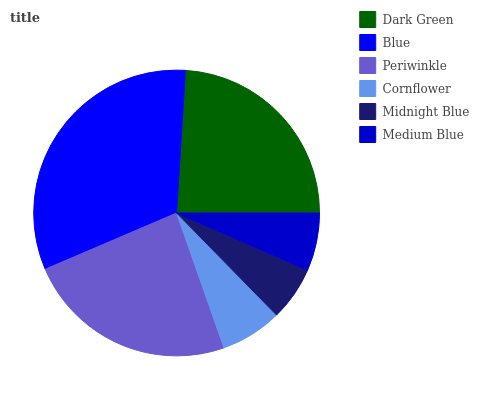Is Midnight Blue the minimum?
Answer yes or no. Yes. Is Blue the maximum?
Answer yes or no. Yes. Is Periwinkle the minimum?
Answer yes or no. No. Is Periwinkle the maximum?
Answer yes or no. No. Is Blue greater than Periwinkle?
Answer yes or no. Yes. Is Periwinkle less than Blue?
Answer yes or no. Yes. Is Periwinkle greater than Blue?
Answer yes or no. No. Is Blue less than Periwinkle?
Answer yes or no. No. Is Periwinkle the high median?
Answer yes or no. Yes. Is Cornflower the low median?
Answer yes or no. Yes. Is Dark Green the high median?
Answer yes or no. No. Is Medium Blue the low median?
Answer yes or no. No. 